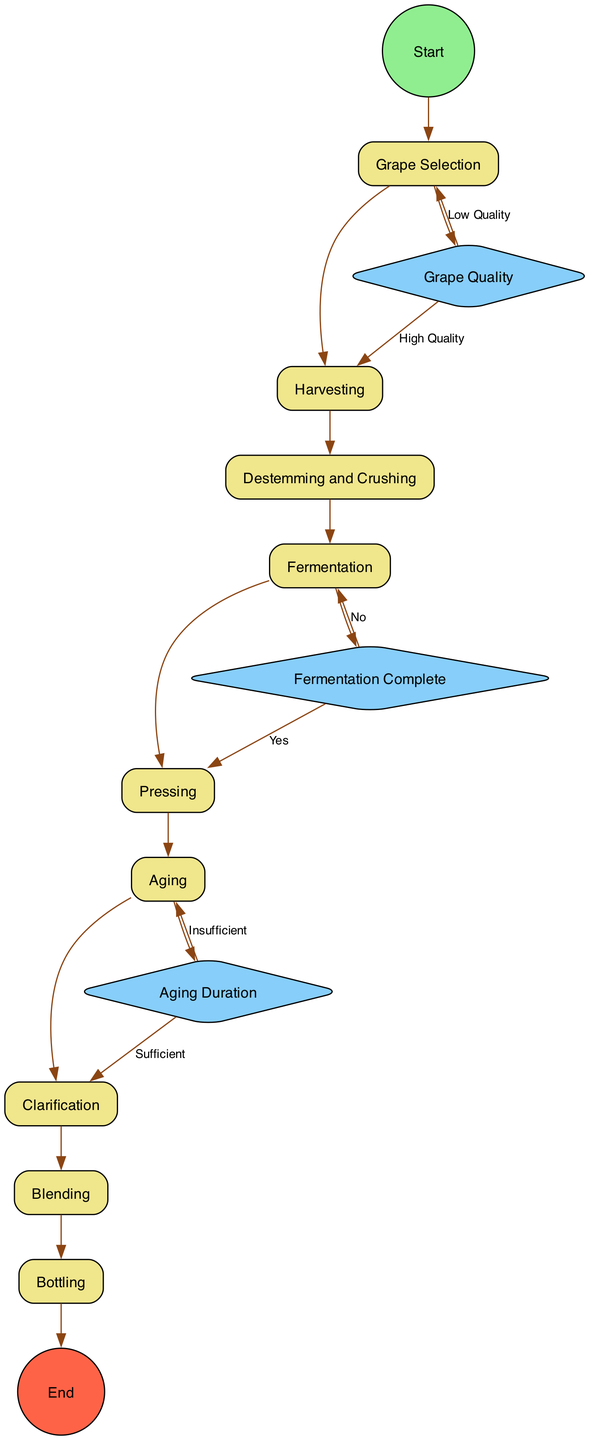What is the starting activity in the diagram? The diagram indicates that the starting activity is labeled "Grape Selection," as shown by the edge leading from the "Start" node to the "Grape Selection" node.
Answer: Grape Selection How many activities are involved in the wine production process? The diagram lists a total of 9 activities: Grape Selection, Harvesting, Destemming and Crushing, Fermentation, Pressing, Aging, Clarification, Blending, and Bottling.
Answer: 9 What does the "Grape Quality Check" decision lead to if the quality is low? According to the branches in the "Grape Quality Check" decision, if the grape quality is low, it leads back to the "Grape Selection" activity.
Answer: Grape Selection Which activity comes immediately after "Fermentation"? From the transitions in the diagram, "Pressing" is the next activity that follows "Fermentation."
Answer: Pressing What decision occurs after the "Aging" activity in the wine production process? The diagram features the "Aging Duration Check" decision that occurs right after "Aging."
Answer: Aging Duration Check What is the final step in the wine production process? The diagram indicates that the final step in the wine production process is "Bottling," which is shown as the end activity.
Answer: Bottling What happens if "Fermentation" is not complete? The "Fermentation Check" decision clarifies that if fermentation is not complete, it loops back to the "Fermentation" activity for further processing.
Answer: Fermentation How many decision points are present in the diagram? The diagram includes 3 decision points: Grape Quality Check, Fermentation Check, and Aging Duration Check.
Answer: 3 What is the condition checked after "Aging"? The condition checked after "Aging" is "Aging Duration," which determines whether to proceed to clarification or remain in the aging process.
Answer: Aging Duration 